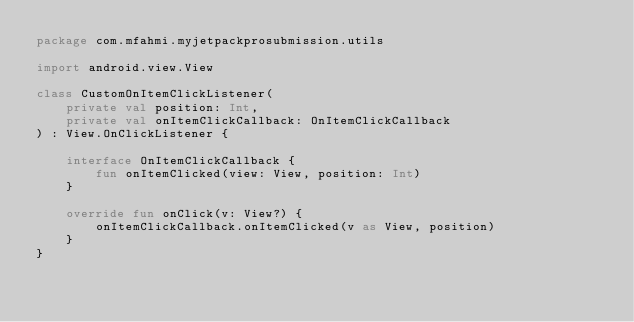<code> <loc_0><loc_0><loc_500><loc_500><_Kotlin_>package com.mfahmi.myjetpackprosubmission.utils

import android.view.View

class CustomOnItemClickListener(
    private val position: Int,
    private val onItemClickCallback: OnItemClickCallback
) : View.OnClickListener {

    interface OnItemClickCallback {
        fun onItemClicked(view: View, position: Int)
    }

    override fun onClick(v: View?) {
        onItemClickCallback.onItemClicked(v as View, position)
    }
}</code> 